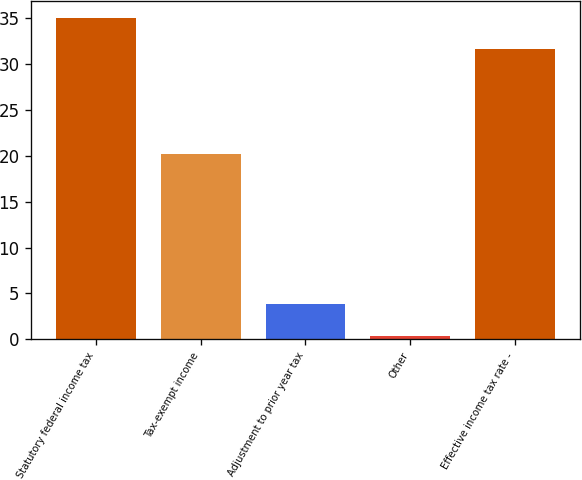Convert chart. <chart><loc_0><loc_0><loc_500><loc_500><bar_chart><fcel>Statutory federal income tax<fcel>Tax-exempt income<fcel>Adjustment to prior year tax<fcel>Other<fcel>Effective income tax rate -<nl><fcel>35.06<fcel>20.2<fcel>3.86<fcel>0.4<fcel>31.6<nl></chart> 